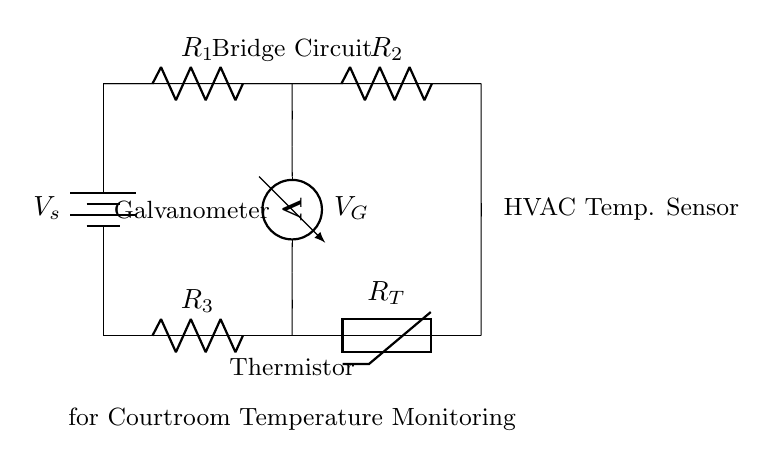What type of circuit is depicted? It is a balanced bridge circuit, which is typically used for measuring unknown resistances using known resistors. The presence of a galvanometer suggests this application.
Answer: balanced bridge circuit What is the function of the thermistor in this circuit? The thermistor is a temperature-dependent resistor that changes its resistance with temperature fluctuations, allowing it to monitor temperature changes in the HVAC system.
Answer: temperature sensor What is the role of the galvanometer? The galvanometer detects the potential difference between the two branches of the bridge circuit, indicating whether the circuit is balanced, which corresponds to a stable temperature reading.
Answer: detect potential difference What is the total resistance of the resistors in the top branch? To find the total resistance in the top branch, you simply add the resistances of R1 and R2, as they are in series.
Answer: R1 + R2 What happens when the temperature rises in the circuit? As the temperature rises, the resistance of the thermistor decreases, causing an unbalance in the bridge which can be measured by the galvanometer, indicating a fluctuation in temperature.
Answer: resistance decreases How is this circuit balanced? The circuit is balanced when the ratio of resistances in one branch equals the ratio in the other branch, leading to zero voltage across the galvanometer.
Answer: equal resistance ratios 